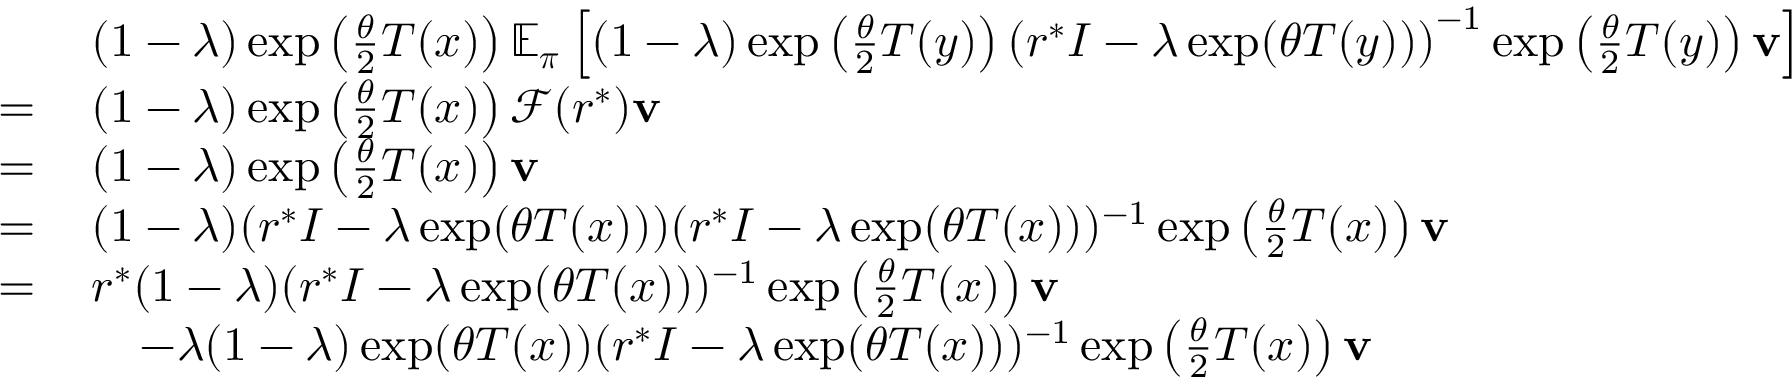<formula> <loc_0><loc_0><loc_500><loc_500>\begin{array} { r l } & { ( 1 - \lambda ) \exp \left ( \frac { \theta } { 2 } T ( x ) \right ) \mathbb { E } _ { \boldsymbol \pi } \left [ ( 1 - \lambda ) \exp \left ( \frac { \theta } { 2 } T ( y ) \right ) \left ( r ^ { * } I - \lambda \exp ( \theta T ( y ) ) \right ) ^ { - 1 } \exp \left ( \frac { \theta } { 2 } T ( y ) \right ) v \right ] } \\ { = \, } & { ( 1 - \lambda ) \exp \left ( \frac { \theta } { 2 } T ( x ) \right ) \mathcal { F } ( r ^ { * } ) v } \\ { = \, } & { ( 1 - \lambda ) \exp \left ( \frac { \theta } { 2 } T ( x ) \right ) v } \\ { = \, } & { ( 1 - \lambda ) ( r ^ { * } I - \lambda \exp ( \theta T ( x ) ) ) ( r ^ { * } I - \lambda \exp ( \theta T ( x ) ) ) ^ { - 1 } \exp \left ( \frac { \theta } { 2 } T ( x ) \right ) v } \\ { = \, } & { r ^ { * } ( 1 - \lambda ) ( r ^ { * } I - \lambda \exp ( \theta T ( x ) ) ) ^ { - 1 } \exp \left ( \frac { \theta } { 2 } T ( x ) \right ) v } \\ & { \quad - \lambda ( 1 - \lambda ) \exp ( \theta T ( x ) ) ( r ^ { * } I - \lambda \exp ( \theta T ( x ) ) ) ^ { - 1 } \exp \left ( \frac { \theta } { 2 } T ( x ) \right ) v } \end{array}</formula> 